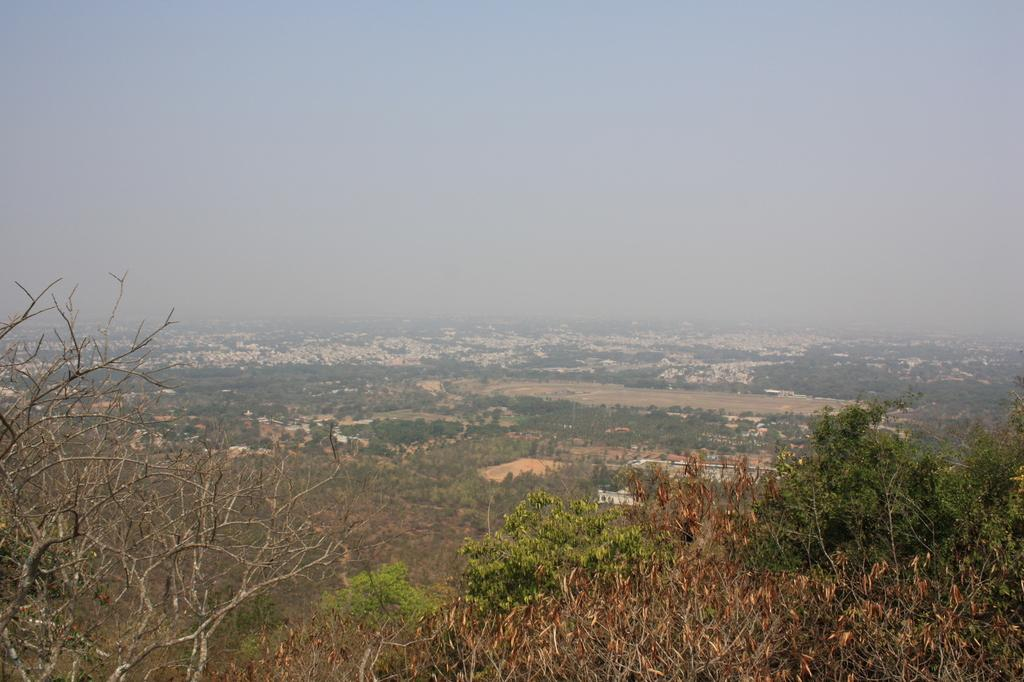What type of vegetation can be seen in the image? There are plants and trees in the image. What can be seen in the background of the image? There are buildings in the background of the image. What type of nut is being used to decorate the crown in the image? There is no nut or crown present in the image; it features plants, trees, and buildings. 